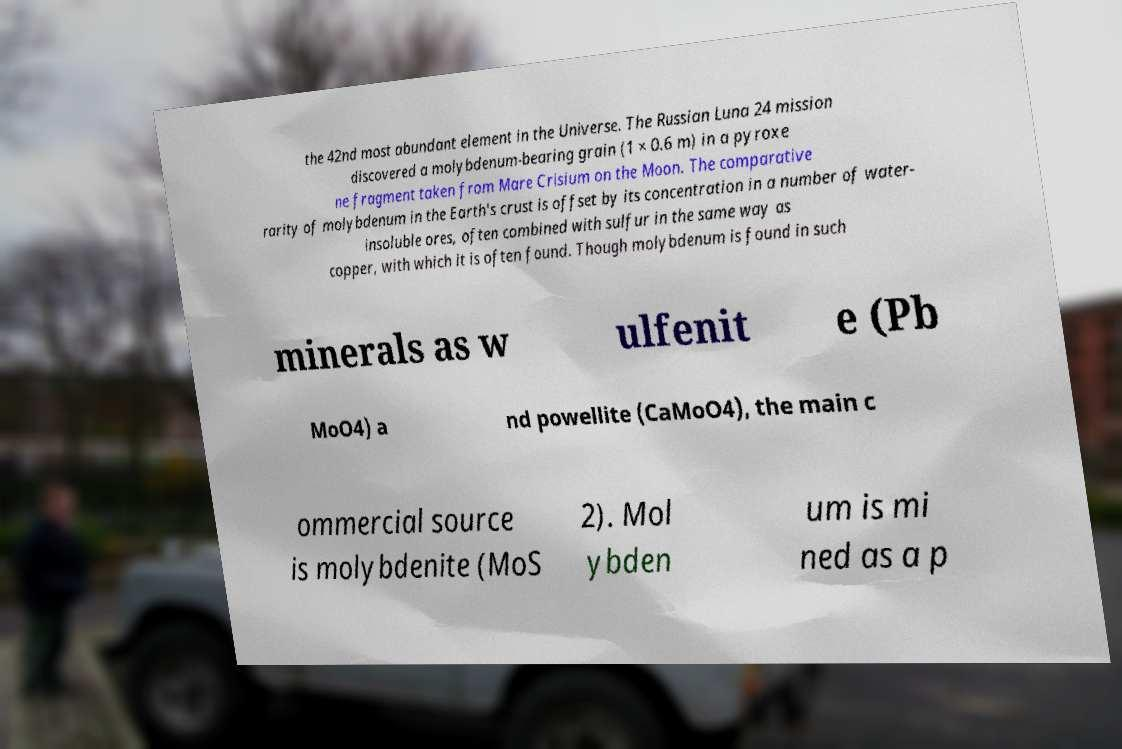What messages or text are displayed in this image? I need them in a readable, typed format. the 42nd most abundant element in the Universe. The Russian Luna 24 mission discovered a molybdenum-bearing grain (1 × 0.6 m) in a pyroxe ne fragment taken from Mare Crisium on the Moon. The comparative rarity of molybdenum in the Earth's crust is offset by its concentration in a number of water- insoluble ores, often combined with sulfur in the same way as copper, with which it is often found. Though molybdenum is found in such minerals as w ulfenit e (Pb MoO4) a nd powellite (CaMoO4), the main c ommercial source is molybdenite (MoS 2). Mol ybden um is mi ned as a p 